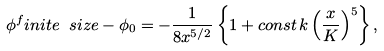Convert formula to latex. <formula><loc_0><loc_0><loc_500><loc_500>\phi ^ { f } i n i t e \ s i z e - \phi _ { 0 } = - \frac { 1 } { 8 x ^ { 5 / 2 } } \left \{ 1 + c o n s t \, k \left ( \frac { x } { K } \right ) ^ { 5 } \right \} ,</formula> 